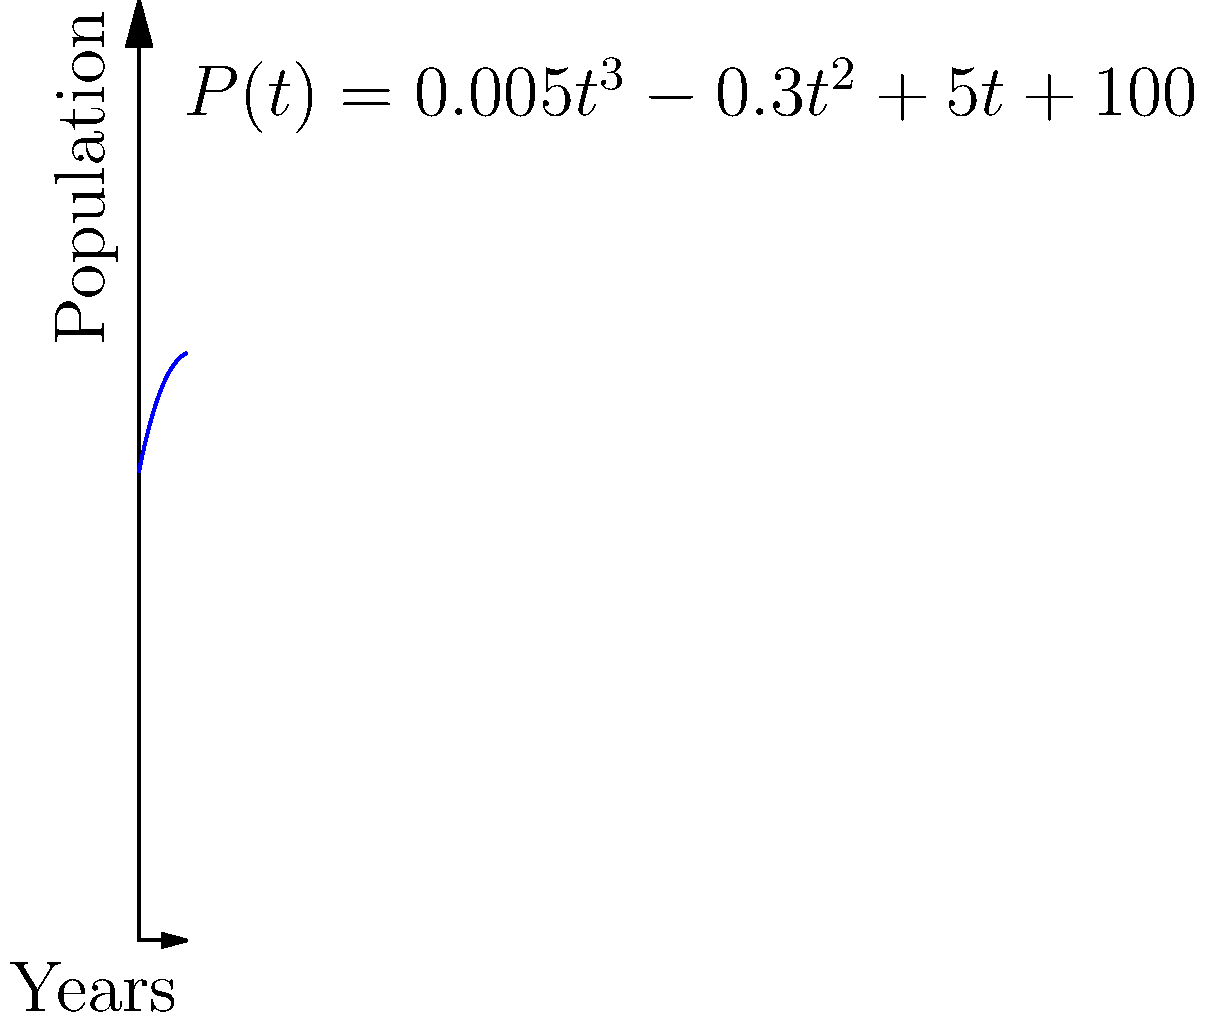As a horse breeder, you're monitoring the population growth of a specific horse breed. The population P(t) after t years can be modeled by the cubic function:

$P(t) = 0.005t^3 - 0.3t^2 + 5t + 100$

where P(t) represents the number of horses and t represents the time in years. After how many years will the population reach its minimum value according to this model? To find the minimum point of the population, we need to follow these steps:

1) The minimum point occurs where the derivative of the function equals zero. So, we need to find $P'(t)$ and set it to zero.

2) $P'(t) = 0.015t^2 - 0.6t + 5$

3) Set $P'(t) = 0$:
   $0.015t^2 - 0.6t + 5 = 0$

4) This is a quadratic equation. We can solve it using the quadratic formula:
   $t = \frac{-b \pm \sqrt{b^2 - 4ac}}{2a}$

   Where $a = 0.015$, $b = -0.6$, and $c = 5$

5) Plugging in these values:
   $t = \frac{0.6 \pm \sqrt{(-0.6)^2 - 4(0.015)(5)}}{2(0.015)}$

6) Simplifying:
   $t = \frac{0.6 \pm \sqrt{0.36 - 0.3}}{0.03} = \frac{0.6 \pm \sqrt{0.06}}{0.03}$

7) This gives us two solutions:
   $t_1 \approx 32.45$ and $t_2 \approx 7.55$

8) Since we're dealing with years, and the graph is only shown for the first 10 years, the relevant minimum occurs at approximately 7.55 years.
Answer: Approximately 7.55 years 